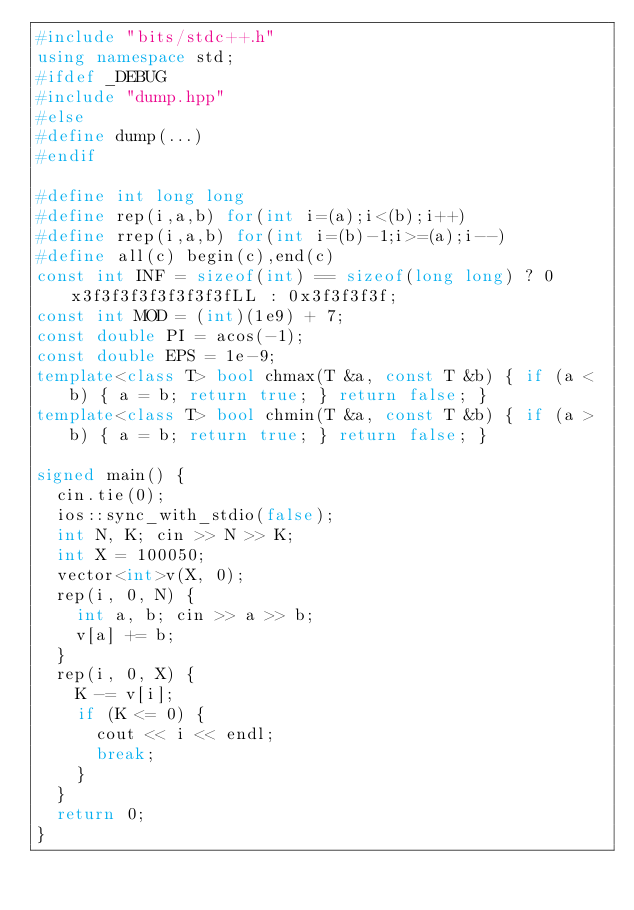<code> <loc_0><loc_0><loc_500><loc_500><_C++_>#include "bits/stdc++.h"
using namespace std;
#ifdef _DEBUG
#include "dump.hpp"
#else
#define dump(...)
#endif

#define int long long
#define rep(i,a,b) for(int i=(a);i<(b);i++)
#define rrep(i,a,b) for(int i=(b)-1;i>=(a);i--)
#define all(c) begin(c),end(c)
const int INF = sizeof(int) == sizeof(long long) ? 0x3f3f3f3f3f3f3f3fLL : 0x3f3f3f3f;
const int MOD = (int)(1e9) + 7;
const double PI = acos(-1);
const double EPS = 1e-9;
template<class T> bool chmax(T &a, const T &b) { if (a < b) { a = b; return true; } return false; }
template<class T> bool chmin(T &a, const T &b) { if (a > b) { a = b; return true; } return false; }

signed main() {
	cin.tie(0);
	ios::sync_with_stdio(false);
	int N, K; cin >> N >> K;
	int X = 100050;
	vector<int>v(X, 0);
	rep(i, 0, N) {
		int a, b; cin >> a >> b;
		v[a] += b;
	}
	rep(i, 0, X) {
		K -= v[i];
		if (K <= 0) {
			cout << i << endl;
			break;
		}
	}
	return 0;
}</code> 